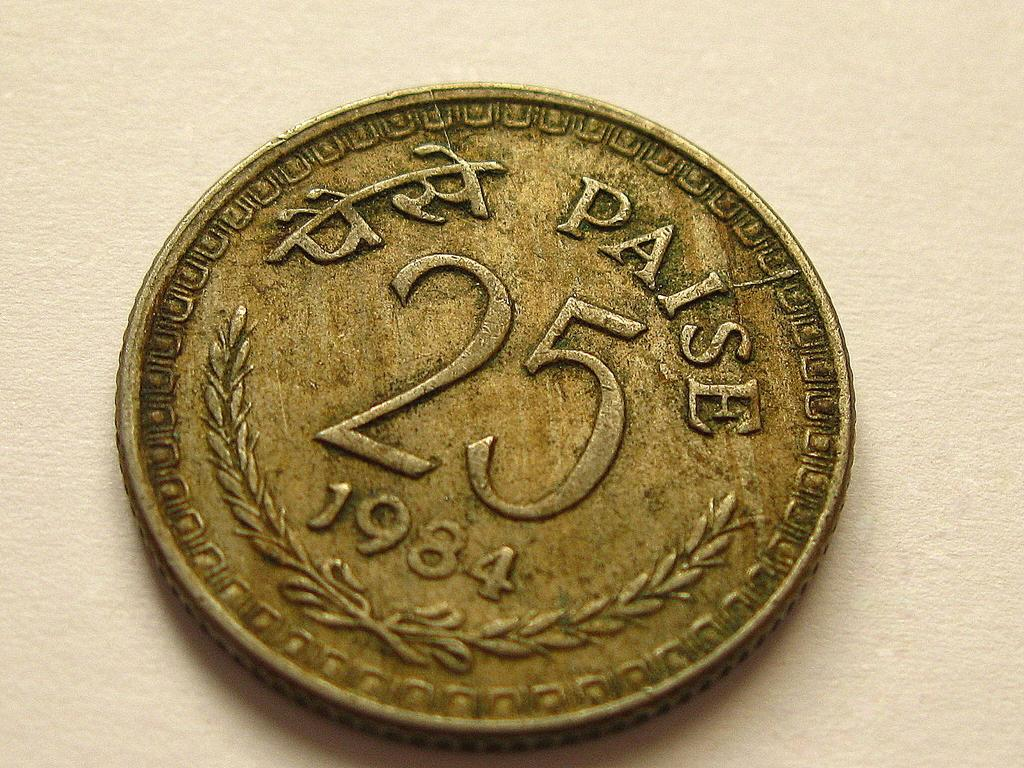<image>
Give a short and clear explanation of the subsequent image. A Paise 25 coin shows that it was minted in 1984. 